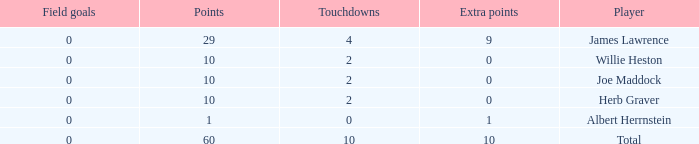What is the highest number of extra points for players with less than 2 touchdowns and less than 1 point? None. 